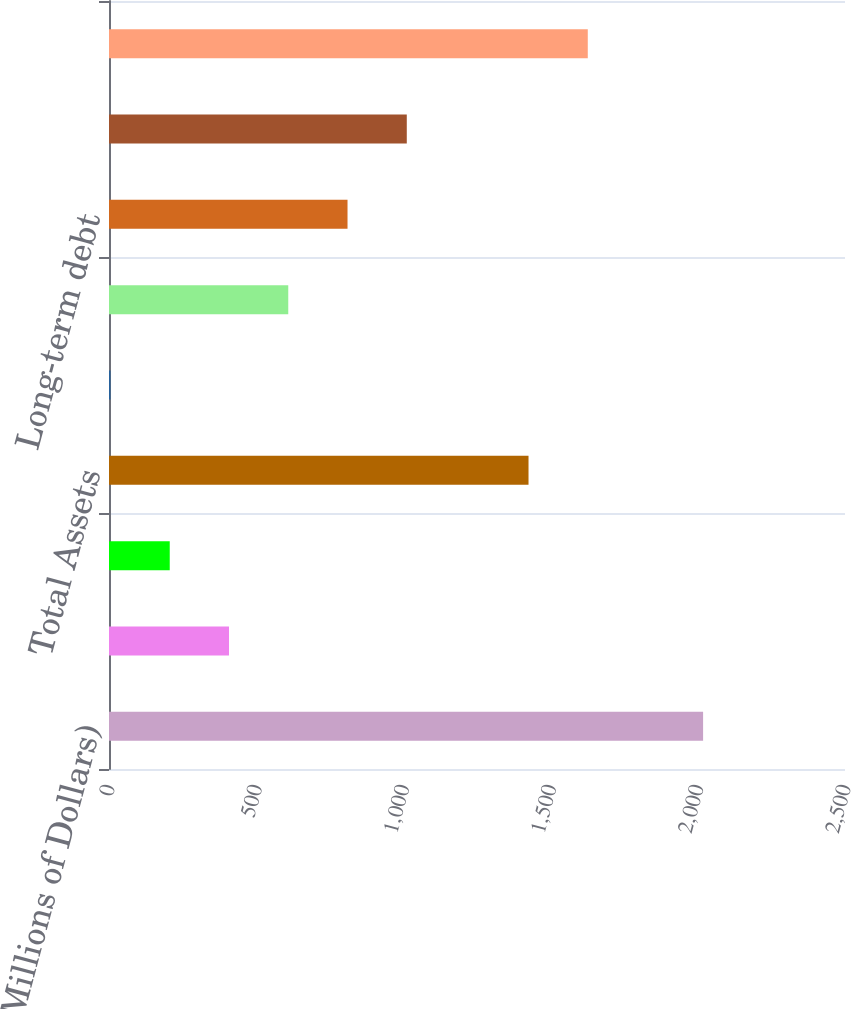Convert chart. <chart><loc_0><loc_0><loc_500><loc_500><bar_chart><fcel>(Millions of Dollars)<fcel>Current assets<fcel>Other noncurrent assets<fcel>Total Assets<fcel>Current liabilities<fcel>Noncurrent liabilities<fcel>Long-term debt<fcel>Equity<fcel>Total liabilities and equity<nl><fcel>2018<fcel>407.6<fcel>206.3<fcel>1425<fcel>5<fcel>608.9<fcel>810.2<fcel>1011.5<fcel>1626.3<nl></chart> 